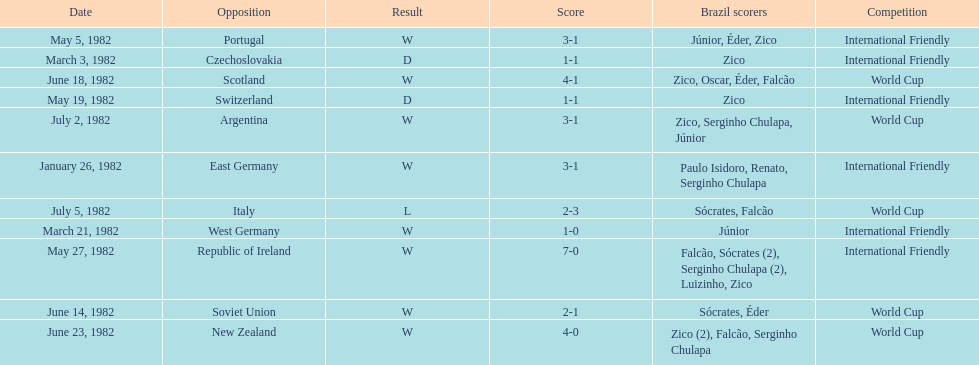Who won on january 26, 1982 and may 27, 1982? Brazil. 